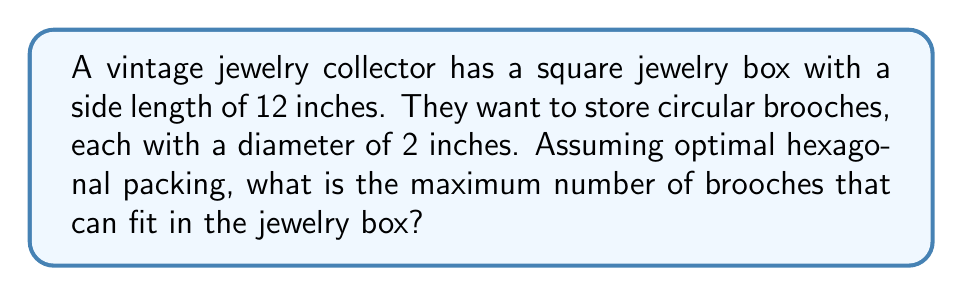Help me with this question. Let's approach this step-by-step:

1) In optimal hexagonal packing, each circle is surrounded by six others, forming a hexagonal lattice.

2) The density of hexagonal packing is:

   $$\frac{\pi}{2\sqrt{3}} \approx 0.9069$$

3) The area of the square jewelry box is:

   $$A_{box} = 12^2 = 144 \text{ square inches}$$

4) The area of each brooch is:

   $$A_{brooch} = \pi r^2 = \pi (1^2) = \pi \text{ square inches}$$

5) The theoretical maximum number of brooches (if we could use partial brooches) would be:

   $$N_{theoretical} = \frac{A_{box} \times \text{packing density}}{A_{brooch}}$$

   $$= \frac{144 \times \frac{\pi}{2\sqrt{3}}}{\pi} = \frac{72}{\sqrt{3}} \approx 41.569$$

6) However, we can only use whole brooches, so we round down to 41.

7) To verify, let's calculate the actual arrangement:
   - The center-to-center distance between brooches is 2 inches.
   - In a 12-inch box, we can fit 6 brooches in a row (12 ÷ 2 = 6).
   - For hexagonal packing, alternate rows are offset by 1 inch.
   - We can fit 5 full rows and 2 partial rows.

8) The arrangement would look like this:

[asy]
unitsize(0.2 inch);
for(int i = 0; i < 6; ++i) {
  for(int j = 0; j < 6; ++j) {
    if((i%2 == 0 && j < 6) || (i%2 == 1 && j < 5)) {
      fill(circle((2*j + (i%2), 2*i), 1), gray(0.8));
      draw(circle((2*j + (i%2), 2*i), 1));
    }
  }
}
draw(box((0,0),(12,12)));
[/asy]

9) Counting the brooches in this arrangement:
   6 + 5 + 6 + 5 + 6 + 5 + (4 + 4) = 41

Therefore, the maximum number of brooches that can fit is 41.
Answer: 41 brooches 